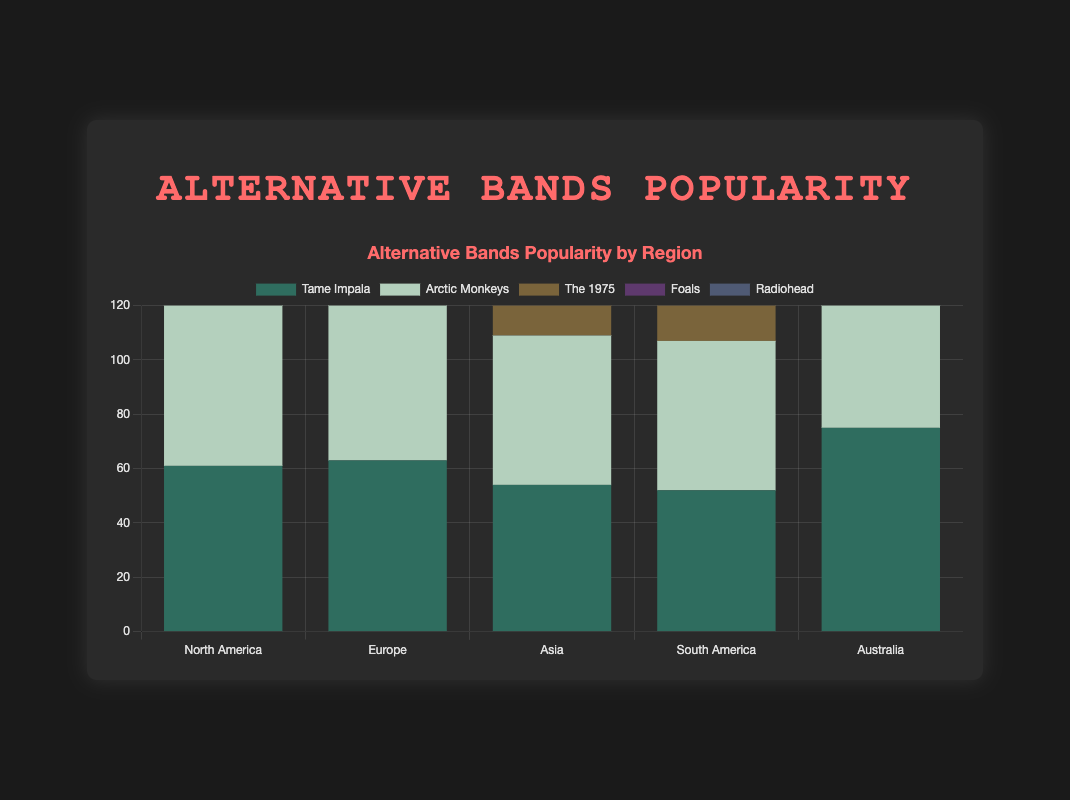Which band has the highest overall popularity in Europe? To determine which band has the highest overall popularity in Europe, compare the total popularity of each band across all age groups in that region. Arctic Monkeys is the most popular with the highest combined bar height in Europe.
Answer: Arctic Monkeys Which age group shows the highest popularity for The 1975 in Asia? By looking at the Asian region for The 1975, it's clear that the age group 15-24 shows the highest popularity as represented by the tallest bar segment.
Answer: 15-24 Calculate the difference in popularity between Arctic Monkeys and Radiohead in North America for the 25-34 age group. In North America, Arctic Monkeys have a popularity of 25 in the 25-34 age group, whereas Radiohead has 20. The difference is 25 - 20 = 5.
Answer: 5 Which band has the least popularity in the 55+ age group across all regions? To find the least popular band in the 55+ age group across all regions, compare the heights of the bands' segments in the respective bars of all regions. Tame Impala has the lowest popularity with the smallest combined segment height.
Answer: Tame Impala Sum up the total popularity of Foals in Australia across all age groups. For Foals in Australia, the popularity values are 21, 24, 15, 9, and 4 for the respective age groups. The sum is 21 + 24 + 15 + 9 + 4 = 73.
Answer: 73 Which region has the highest popularity for Radiohead in the 45-54 age group? By examining the 45-54 age group segments for Radiohead in all regions, Europe shows the highest segment bar height, indicating the highest popularity.
Answer: Europe Compare the total popularity of Tame Impala and The 1975 in South America. Which band is more popular overall? Summing the popularity of Tame Impala in South America gives us 12 + 19 + 10 + 8 + 3 = 52. For The 1975, the sum is 16 + 19 + 12 + 6 + 3 = 56. The 1975 is more popular overall.
Answer: The 1975 Which band shows the most consistent popularity across all age groups in North America? To determine consistency, check for relatively uniform bar segment heights across all age groups in North America. Arctic Monkeys show fairly consistent popularity with no large fluctuations.
Answer: Arctic Monkeys Calculate the average popularity of Foals across all age groups in Europe. For Foals in Europe, the popularity values are 20, 25, 14, 9, and 4. The sum is 20 + 25 + 14 + 9 + 4 = 72, and there are 5 groups, so the average is 72 / 5 = 14.4.
Answer: 14.4 What is the combined popularity of Arctic Monkeys and Radiohead for the 15-24 age group in Asia? Adding the popularity of Arctic Monkeys and Radiohead in Asia for the 15-24 age group gives us 19 + 14 = 33.
Answer: 33 